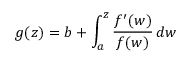Convert formula to latex. <formula><loc_0><loc_0><loc_500><loc_500>g ( z ) = b + \int _ { a } ^ { z } { \frac { f ^ { \prime } ( w ) } { f ( w ) } } \, d w</formula> 